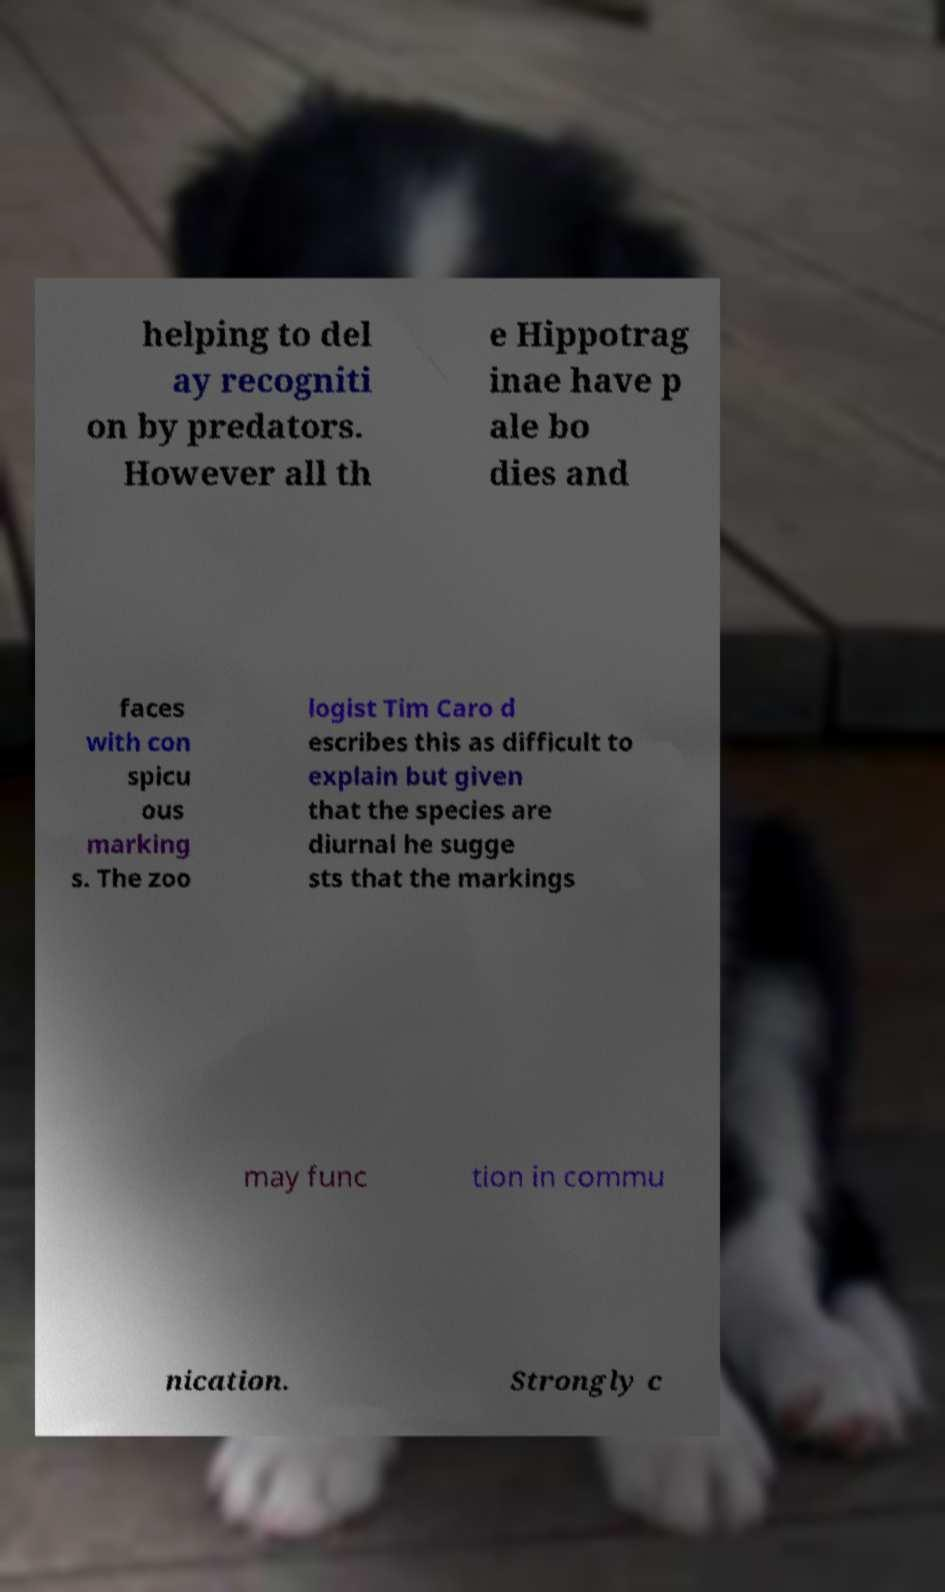What messages or text are displayed in this image? I need them in a readable, typed format. helping to del ay recogniti on by predators. However all th e Hippotrag inae have p ale bo dies and faces with con spicu ous marking s. The zoo logist Tim Caro d escribes this as difficult to explain but given that the species are diurnal he sugge sts that the markings may func tion in commu nication. Strongly c 